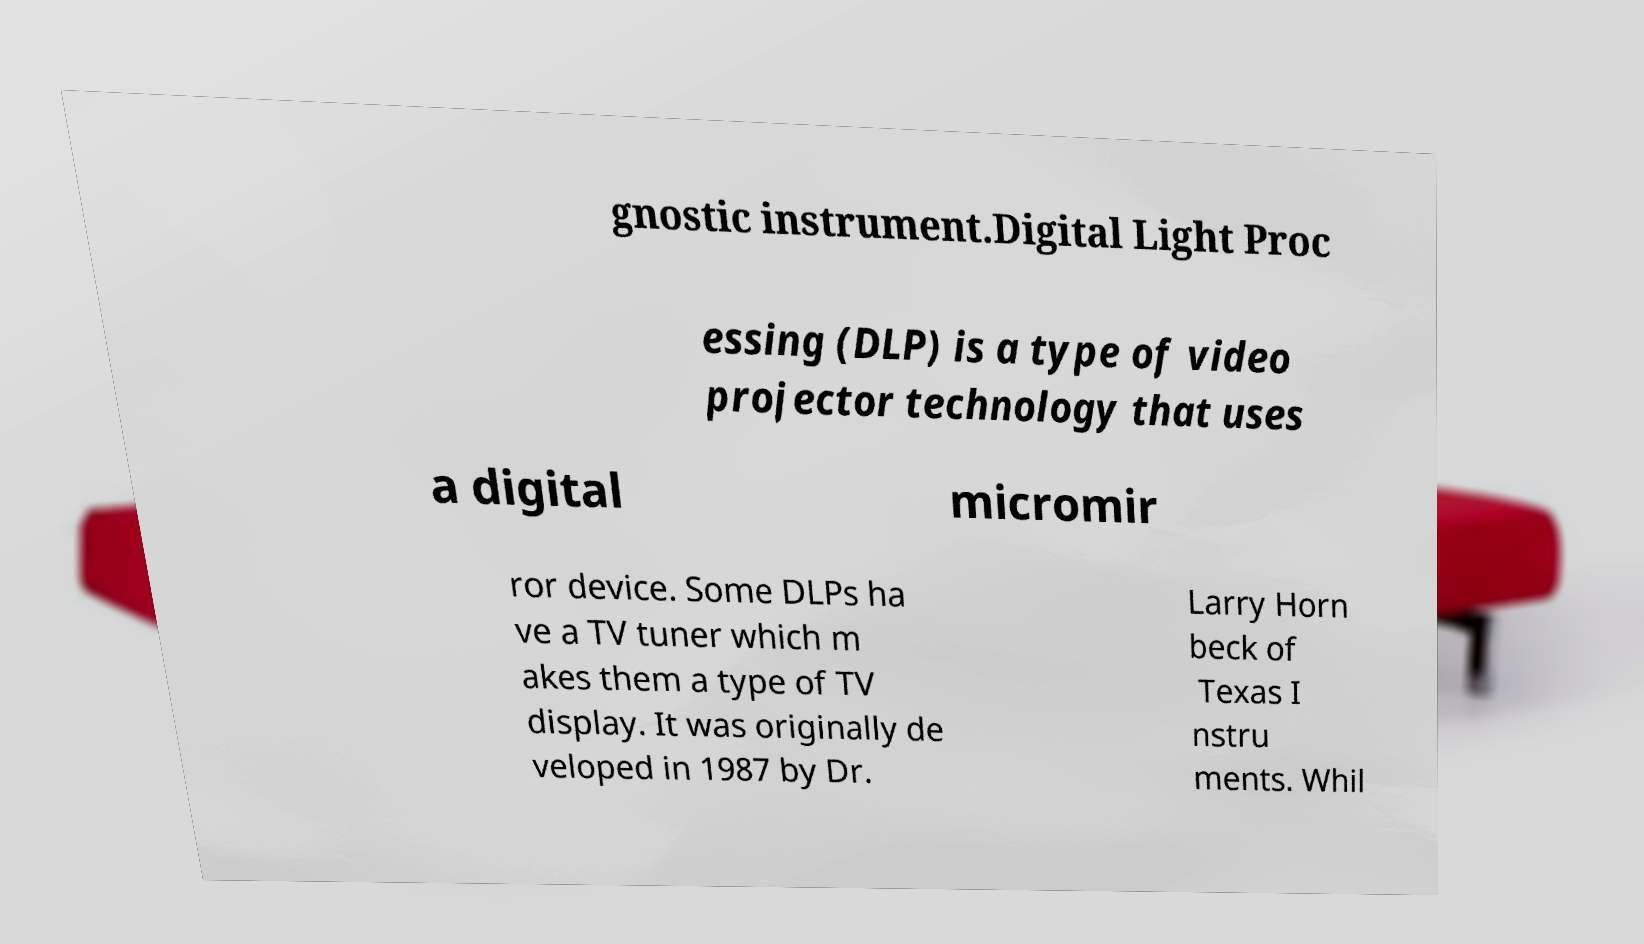There's text embedded in this image that I need extracted. Can you transcribe it verbatim? gnostic instrument.Digital Light Proc essing (DLP) is a type of video projector technology that uses a digital micromir ror device. Some DLPs ha ve a TV tuner which m akes them a type of TV display. It was originally de veloped in 1987 by Dr. Larry Horn beck of Texas I nstru ments. Whil 